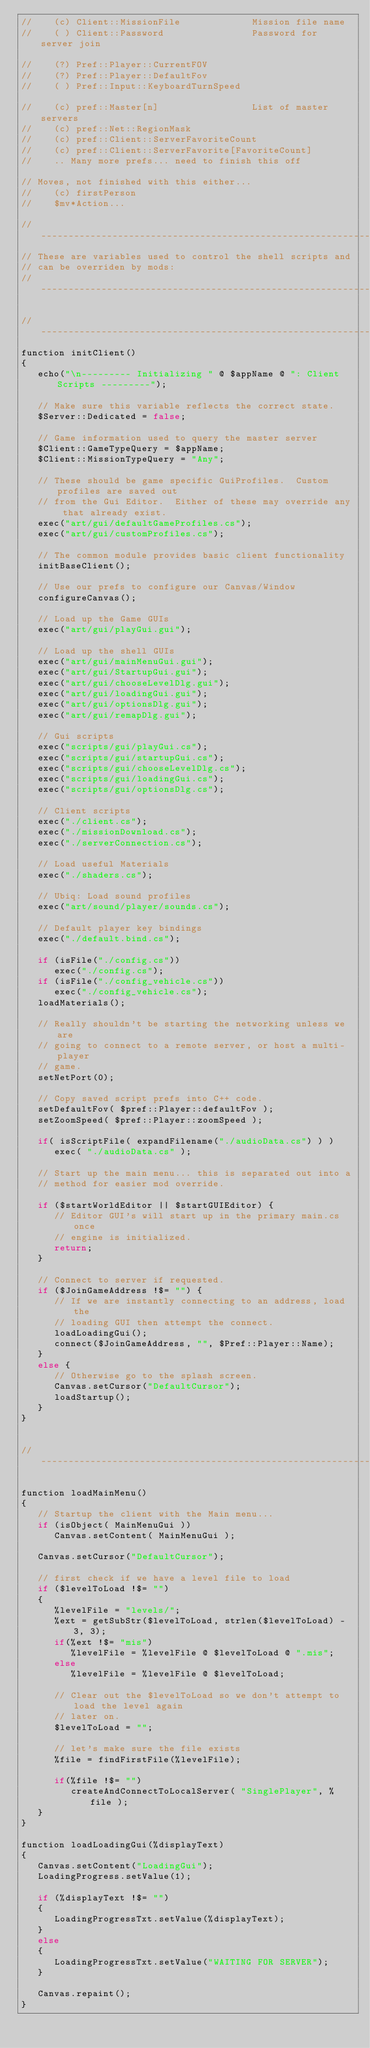<code> <loc_0><loc_0><loc_500><loc_500><_C#_>//    (c) Client::MissionFile             Mission file name
//    ( ) Client::Password                Password for server join

//    (?) Pref::Player::CurrentFOV
//    (?) Pref::Player::DefaultFov
//    ( ) Pref::Input::KeyboardTurnSpeed

//    (c) pref::Master[n]                 List of master servers
//    (c) pref::Net::RegionMask
//    (c) pref::Client::ServerFavoriteCount
//    (c) pref::Client::ServerFavorite[FavoriteCount]
//    .. Many more prefs... need to finish this off

// Moves, not finished with this either...
//    (c) firstPerson
//    $mv*Action...

//-----------------------------------------------------------------------------
// These are variables used to control the shell scripts and
// can be overriden by mods:
//-----------------------------------------------------------------------------

//-----------------------------------------------------------------------------
function initClient()
{
   echo("\n--------- Initializing " @ $appName @ ": Client Scripts ---------");

   // Make sure this variable reflects the correct state.
   $Server::Dedicated = false;

   // Game information used to query the master server
   $Client::GameTypeQuery = $appName;
   $Client::MissionTypeQuery = "Any";

   // These should be game specific GuiProfiles.  Custom profiles are saved out
   // from the Gui Editor.  Either of these may override any that already exist.
   exec("art/gui/defaultGameProfiles.cs");
   exec("art/gui/customProfiles.cs"); 
   
   // The common module provides basic client functionality
   initBaseClient();

   // Use our prefs to configure our Canvas/Window
   configureCanvas();

   // Load up the Game GUIs
   exec("art/gui/playGui.gui");

   // Load up the shell GUIs
   exec("art/gui/mainMenuGui.gui");
   exec("art/gui/StartupGui.gui");
   exec("art/gui/chooseLevelDlg.gui");
   exec("art/gui/loadingGui.gui");
   exec("art/gui/optionsDlg.gui");
   exec("art/gui/remapDlg.gui");
   
   // Gui scripts
   exec("scripts/gui/playGui.cs");
   exec("scripts/gui/startupGui.cs");
   exec("scripts/gui/chooseLevelDlg.cs");
   exec("scripts/gui/loadingGui.cs");
   exec("scripts/gui/optionsDlg.cs");

   // Client scripts
   exec("./client.cs");
   exec("./missionDownload.cs");
   exec("./serverConnection.cs");

   // Load useful Materials
   exec("./shaders.cs");

   // Ubiq: Load sound profiles
   exec("art/sound/player/sounds.cs");

   // Default player key bindings
   exec("./default.bind.cs");

   if (isFile("./config.cs"))
      exec("./config.cs");
   if (isFile("./config_vehicle.cs"))
      exec("./config_vehicle.cs");
   loadMaterials();

   // Really shouldn't be starting the networking unless we are
   // going to connect to a remote server, or host a multi-player
   // game.
   setNetPort(0);

   // Copy saved script prefs into C++ code.
   setDefaultFov( $pref::Player::defaultFov );
   setZoomSpeed( $pref::Player::zoomSpeed );

   if( isScriptFile( expandFilename("./audioData.cs") ) )
      exec( "./audioData.cs" );

   // Start up the main menu... this is separated out into a
   // method for easier mod override.

   if ($startWorldEditor || $startGUIEditor) {
      // Editor GUI's will start up in the primary main.cs once
      // engine is initialized.
      return;
   }

   // Connect to server if requested.
   if ($JoinGameAddress !$= "") {
      // If we are instantly connecting to an address, load the
      // loading GUI then attempt the connect.
      loadLoadingGui();
      connect($JoinGameAddress, "", $Pref::Player::Name);
   }
   else {
      // Otherwise go to the splash screen.
      Canvas.setCursor("DefaultCursor");
      loadStartup();
   }   
}


//-----------------------------------------------------------------------------

function loadMainMenu()
{
   // Startup the client with the Main menu...
   if (isObject( MainMenuGui ))
      Canvas.setContent( MainMenuGui );
   
   Canvas.setCursor("DefaultCursor");

   // first check if we have a level file to load
   if ($levelToLoad !$= "")
   {
      %levelFile = "levels/";
      %ext = getSubStr($levelToLoad, strlen($levelToLoad) - 3, 3);
      if(%ext !$= "mis")
         %levelFile = %levelFile @ $levelToLoad @ ".mis";
      else
         %levelFile = %levelFile @ $levelToLoad;

      // Clear out the $levelToLoad so we don't attempt to load the level again
      // later on.
      $levelToLoad = "";
      
      // let's make sure the file exists
      %file = findFirstFile(%levelFile);

      if(%file !$= "")
         createAndConnectToLocalServer( "SinglePlayer", %file );
   }
}

function loadLoadingGui(%displayText)
{
   Canvas.setContent("LoadingGui");
   LoadingProgress.setValue(1);

   if (%displayText !$= "")
   {
      LoadingProgressTxt.setValue(%displayText);
   }
   else
   {
      LoadingProgressTxt.setValue("WAITING FOR SERVER");
   }

   Canvas.repaint();
}
</code> 